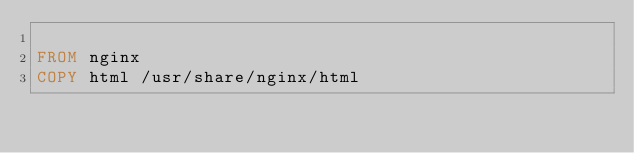<code> <loc_0><loc_0><loc_500><loc_500><_Dockerfile_>
FROM nginx
COPY html /usr/share/nginx/html
</code> 